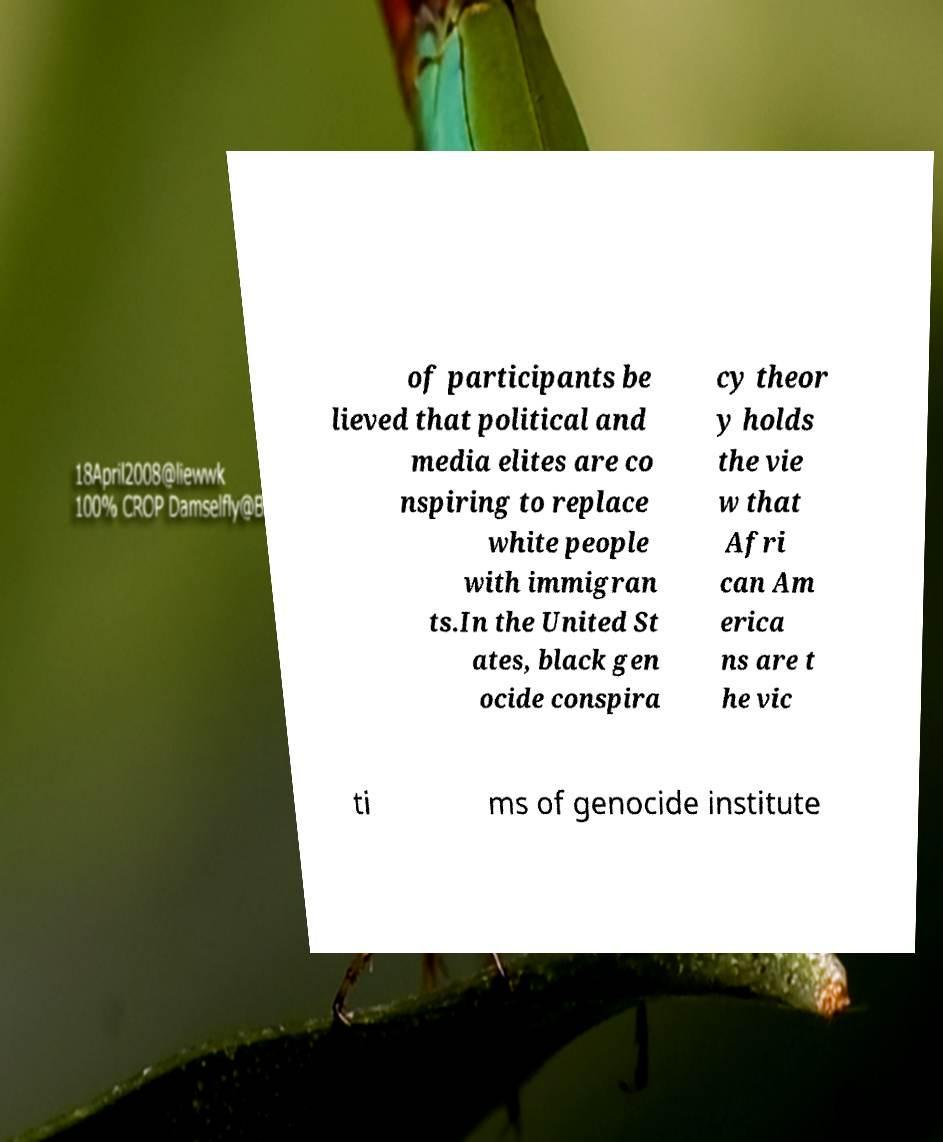I need the written content from this picture converted into text. Can you do that? of participants be lieved that political and media elites are co nspiring to replace white people with immigran ts.In the United St ates, black gen ocide conspira cy theor y holds the vie w that Afri can Am erica ns are t he vic ti ms of genocide institute 